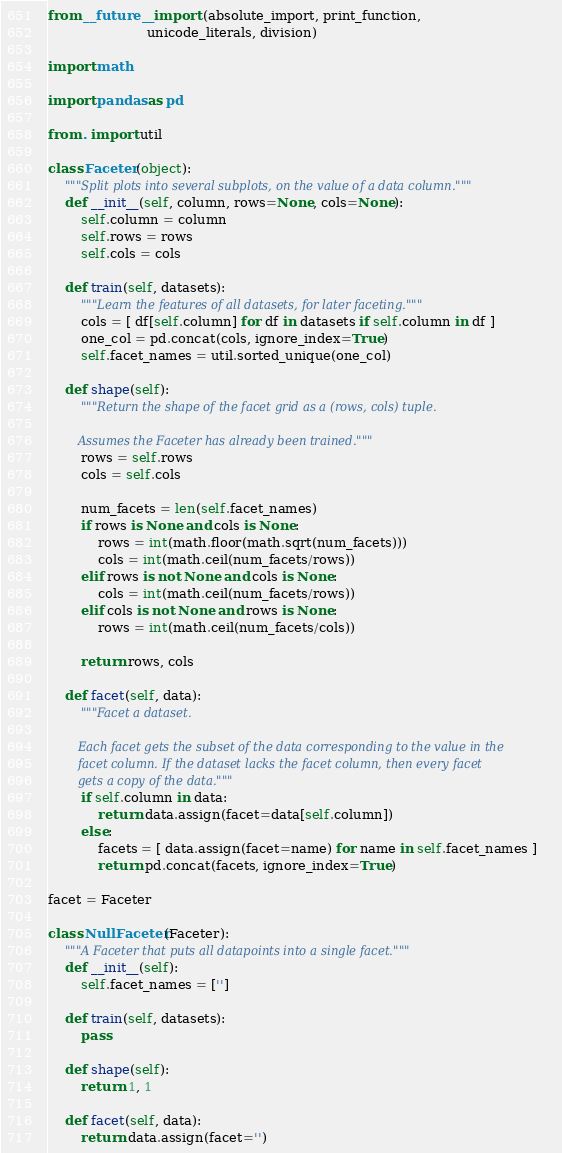<code> <loc_0><loc_0><loc_500><loc_500><_Python_>from __future__ import (absolute_import, print_function,
                        unicode_literals, division)

import math

import pandas as pd

from . import util

class Faceter(object):
    """Split plots into several subplots, on the value of a data column."""
    def __init__(self, column, rows=None, cols=None):
        self.column = column
        self.rows = rows
        self.cols = cols

    def train(self, datasets):
        """Learn the features of all datasets, for later faceting."""
        cols = [ df[self.column] for df in datasets if self.column in df ]
        one_col = pd.concat(cols, ignore_index=True)
        self.facet_names = util.sorted_unique(one_col)

    def shape(self):
        """Return the shape of the facet grid as a (rows, cols) tuple.

        Assumes the Faceter has already been trained."""
        rows = self.rows
        cols = self.cols

        num_facets = len(self.facet_names)
        if rows is None and cols is None:
            rows = int(math.floor(math.sqrt(num_facets)))
            cols = int(math.ceil(num_facets/rows))
        elif rows is not None and cols is None:
            cols = int(math.ceil(num_facets/rows))
        elif cols is not None and rows is None:
            rows = int(math.ceil(num_facets/cols))

        return rows, cols

    def facet(self, data):
        """Facet a dataset.

        Each facet gets the subset of the data corresponding to the value in the
        facet column. If the dataset lacks the facet column, then every facet
        gets a copy of the data."""
        if self.column in data:
            return data.assign(facet=data[self.column])
        else:
            facets = [ data.assign(facet=name) for name in self.facet_names ]
            return pd.concat(facets, ignore_index=True)

facet = Faceter

class NullFaceter(Faceter):
    """A Faceter that puts all datapoints into a single facet."""
    def __init__(self):
        self.facet_names = ['']

    def train(self, datasets):
        pass

    def shape(self):
        return 1, 1

    def facet(self, data):
        return data.assign(facet='')
</code> 